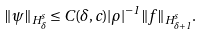<formula> <loc_0><loc_0><loc_500><loc_500>\| \psi \| _ { H ^ { s } _ { \delta } } \leq C ( \delta , c ) | \rho | ^ { - 1 } \| f \| _ { H ^ { s } _ { \delta + 1 } } .</formula> 